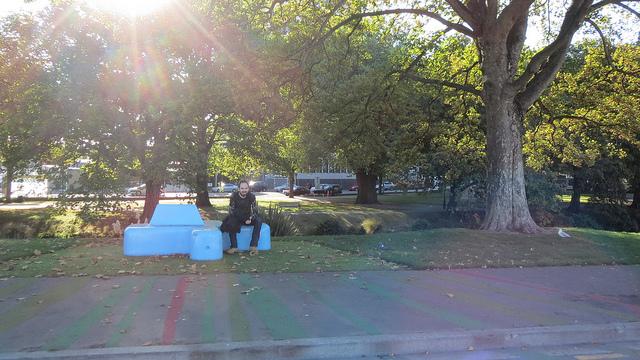Is he sitting in a park?
Answer briefly. Yes. Is there a bench in the image?
Keep it brief. Yes. What color is the thing the man is sitting on?
Concise answer only. Blue. 